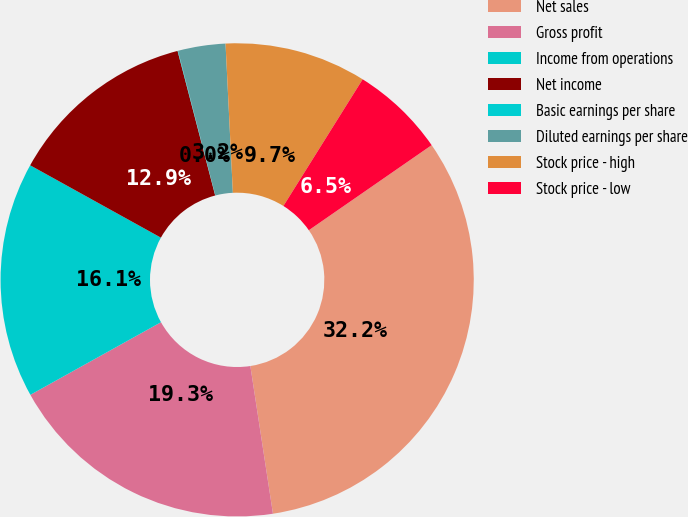<chart> <loc_0><loc_0><loc_500><loc_500><pie_chart><fcel>Net sales<fcel>Gross profit<fcel>Income from operations<fcel>Net income<fcel>Basic earnings per share<fcel>Diluted earnings per share<fcel>Stock price - high<fcel>Stock price - low<nl><fcel>32.22%<fcel>19.34%<fcel>16.12%<fcel>12.9%<fcel>0.03%<fcel>3.24%<fcel>9.68%<fcel>6.46%<nl></chart> 